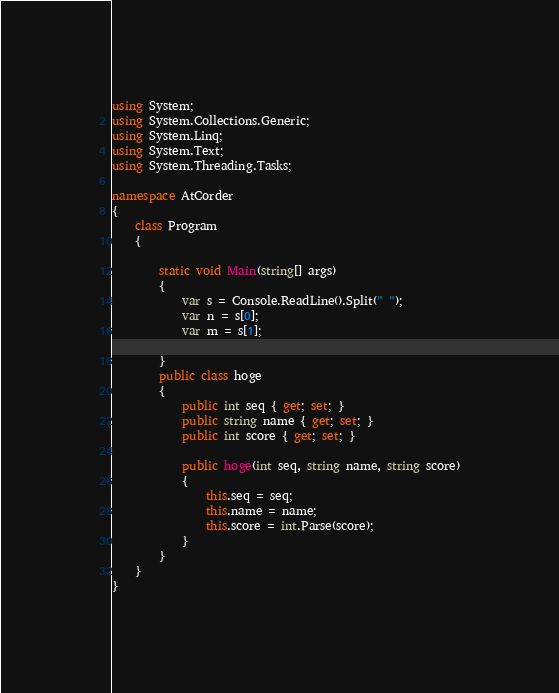<code> <loc_0><loc_0><loc_500><loc_500><_C#_>using System;
using System.Collections.Generic;
using System.Linq;
using System.Text;
using System.Threading.Tasks;

namespace AtCorder
{
    class Program
    {

        static void Main(string[] args)
        {
            var s = Console.ReadLine().Split(" ");
            var n = s[0];
            var m = s[1];

        }
        public class hoge
        {
            public int seq { get; set; }
            public string name { get; set; }
            public int score { get; set; }

            public hoge(int seq, string name, string score)
            {
                this.seq = seq;
                this.name = name;
                this.score = int.Parse(score);
            }
        }
    }
}</code> 